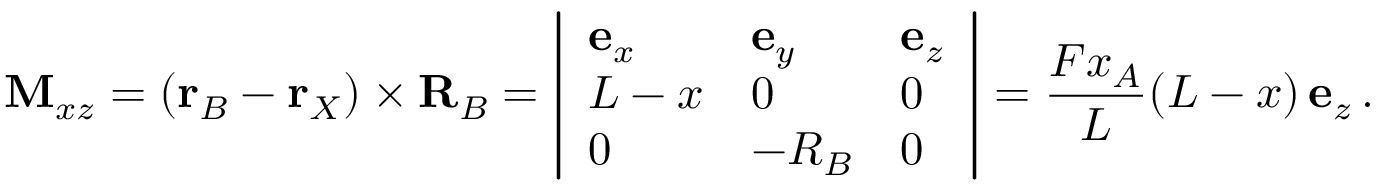<formula> <loc_0><loc_0><loc_500><loc_500>M _ { x z } = ( r _ { B } - r _ { X } ) \times R _ { B } = \left | { \begin{array} { l l l } { e _ { x } } & { e _ { y } } & { e _ { z } } \\ { L - x } & { 0 } & { 0 } \\ { 0 } & { - R _ { B } } & { 0 } \end{array} } \right | = { \frac { F x _ { A } } { L } } ( L - x ) \, e _ { z } \, .</formula> 